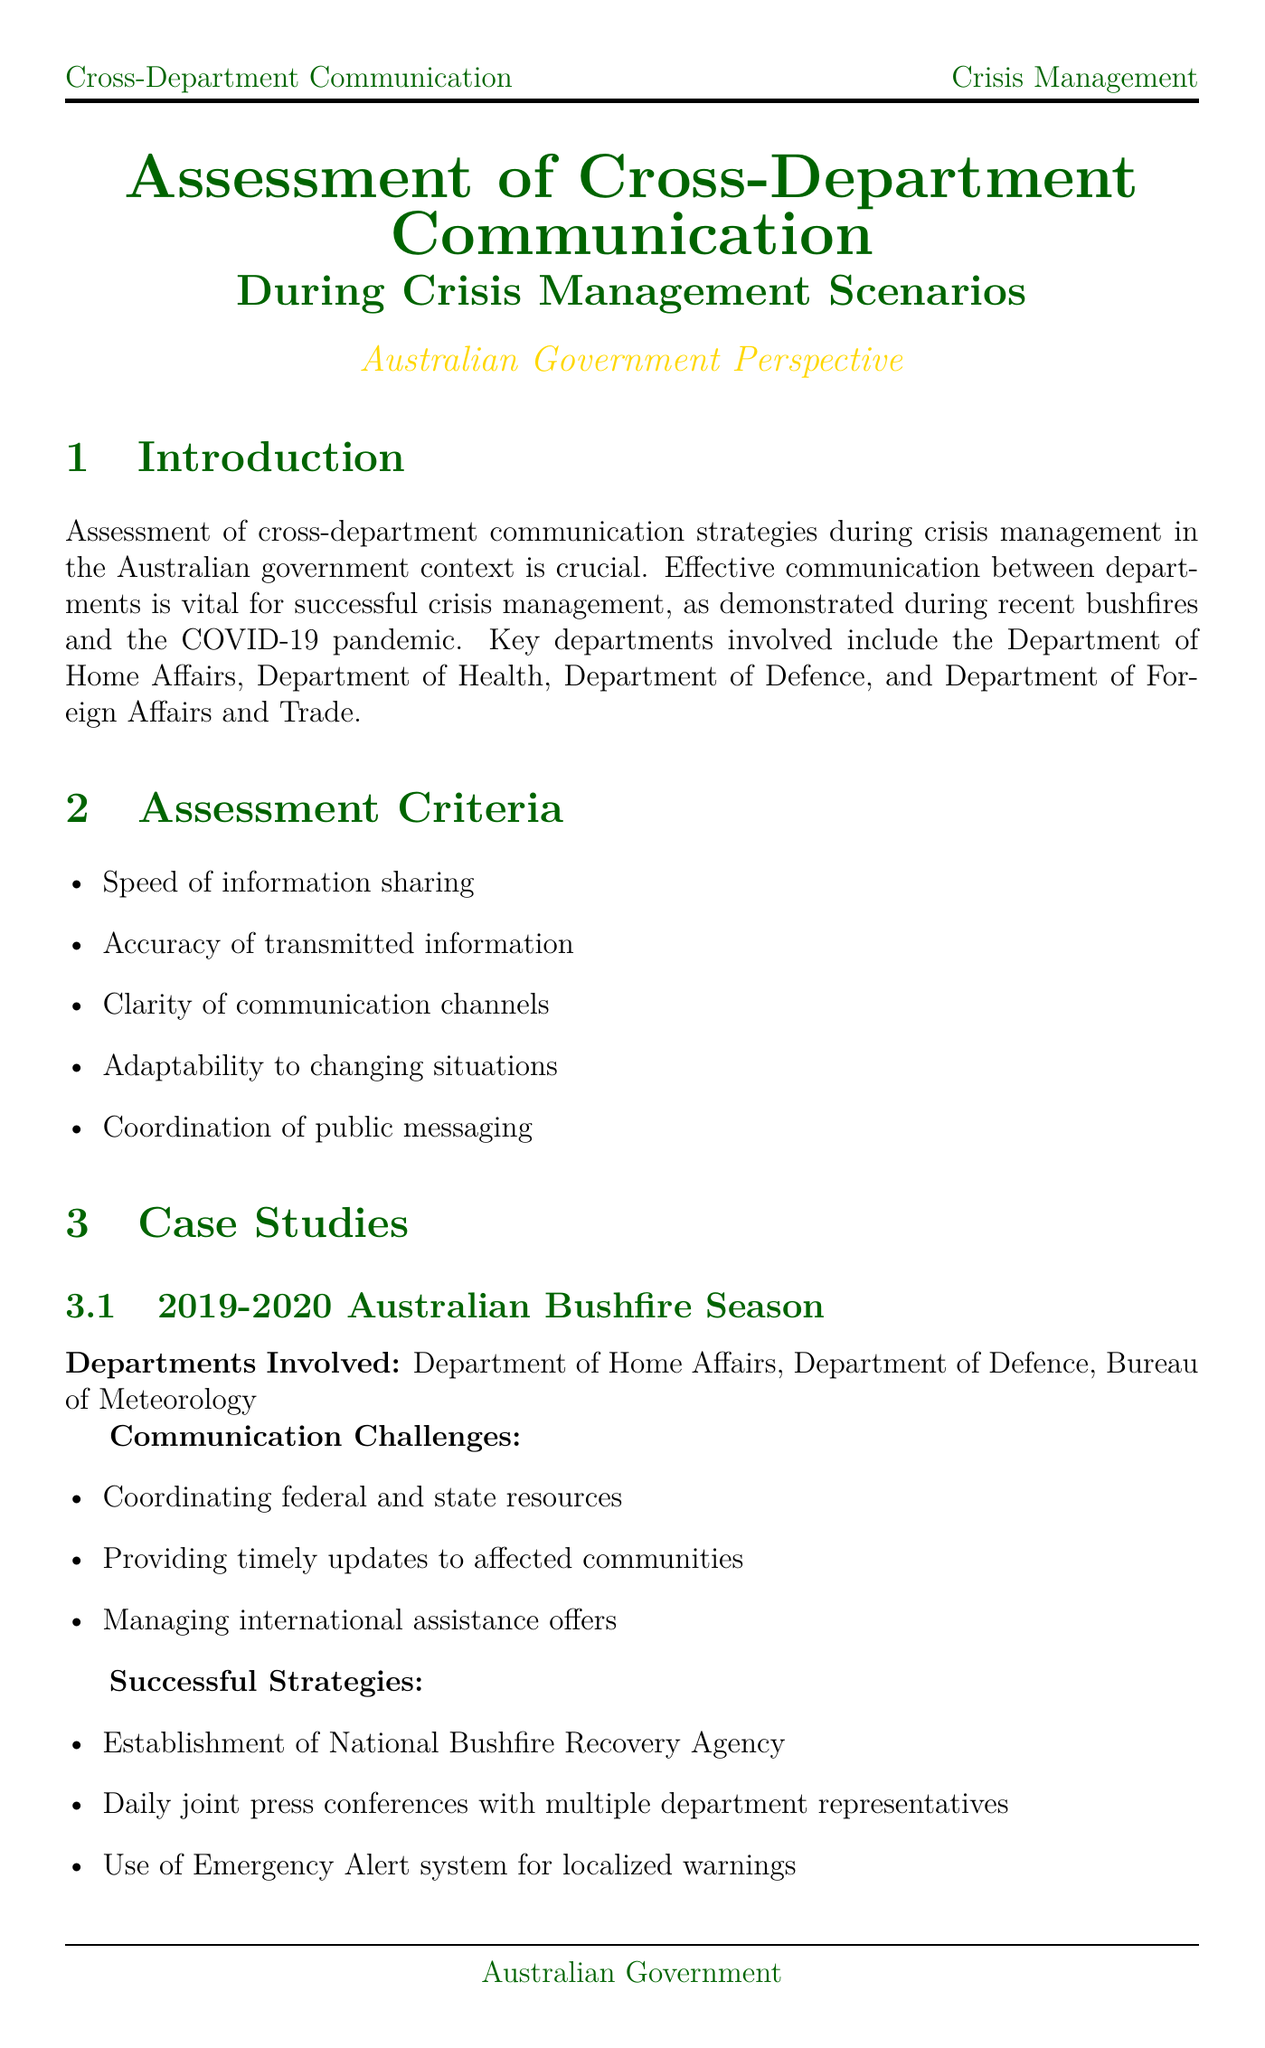what is the primary focus of the document? The document assesses cross-department communication strategies during crisis management in the context of the Australian government.
Answer: assessment of cross-department communication which two departments were involved in the Australian Bushfire Season case study? The case study mentions the Department of Home Affairs and the Department of Defence as involved departments.
Answer: Department of Home Affairs, Department of Defence what is one of the communication challenges faced during the COVID-19 pandemic response? One communication challenge was the rapidly evolving situation requiring frequent updates.
Answer: rapidly evolving situation requiring frequent updates how many assessment criteria are mentioned in the document? The document lists five assessment criteria for evaluating communication strategies.
Answer: five what is one recommended solution to bureaucratic silos? The recommendation is to implement cross-departmental crisis management teams with representatives from each relevant agency.
Answer: implement cross-departmental crisis management teams with representatives from each relevant agency name one communication tool used by the Australian government agencies. Government agencies use GovTEAMS as a secure collaboration platform.
Answer: GovTEAMS what key takeaway emphasizes the necessity of technology in future preparedness? Leveraging technology and fostering a collaborative culture are essential for future preparedness.
Answer: Leveraging technology and fostering a collaborative culture which major technological advancement is mentioned for crisis management? The document mentions AI-powered crisis prediction and simulation tools as a technological advancement.
Answer: AI-powered crisis prediction and simulation tools what is the call to action at the end of the document? The call to action emphasizes the continuous evaluation and refinement of communication strategies for future crises.
Answer: Continuous evaluation and refinement of cross-department communication strategies 